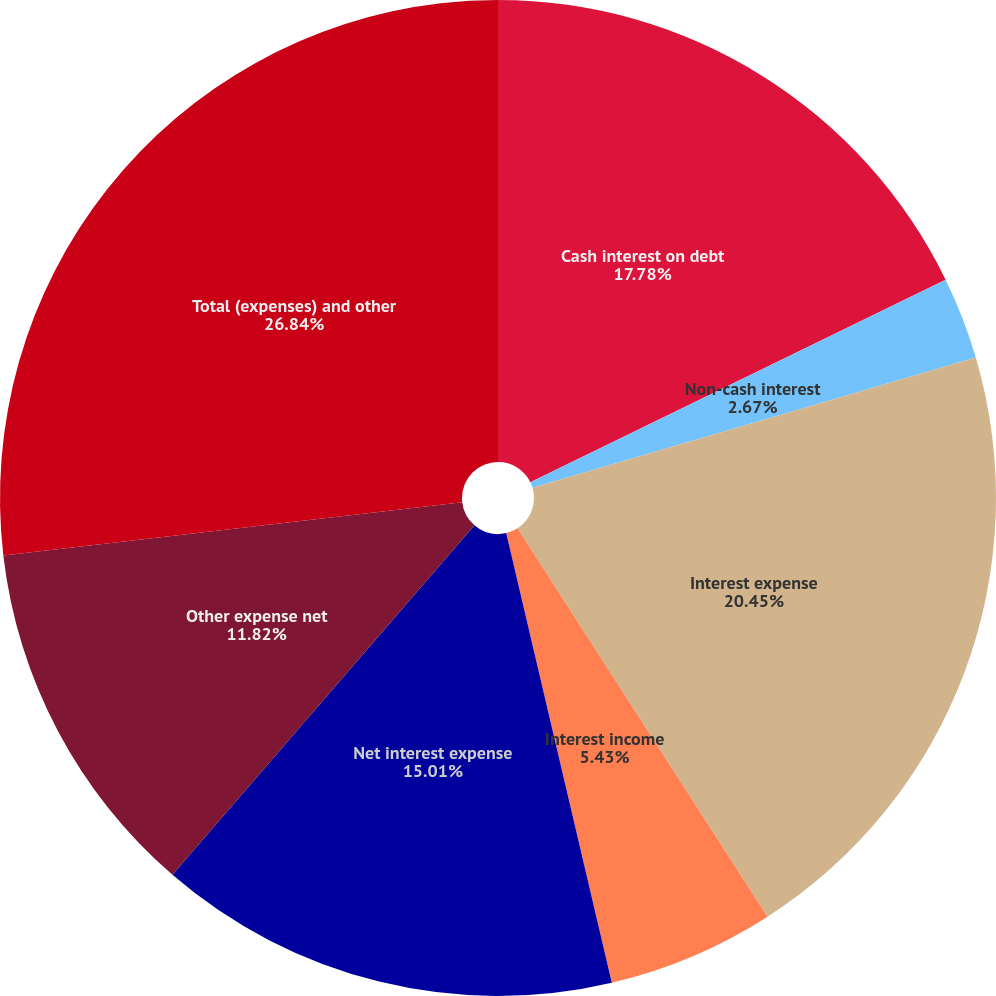Convert chart to OTSL. <chart><loc_0><loc_0><loc_500><loc_500><pie_chart><fcel>Cash interest on debt<fcel>Non-cash interest<fcel>Interest expense<fcel>Interest income<fcel>Net interest expense<fcel>Other expense net<fcel>Total (expenses) and other<nl><fcel>17.78%<fcel>2.67%<fcel>20.45%<fcel>5.43%<fcel>15.01%<fcel>11.82%<fcel>26.84%<nl></chart> 